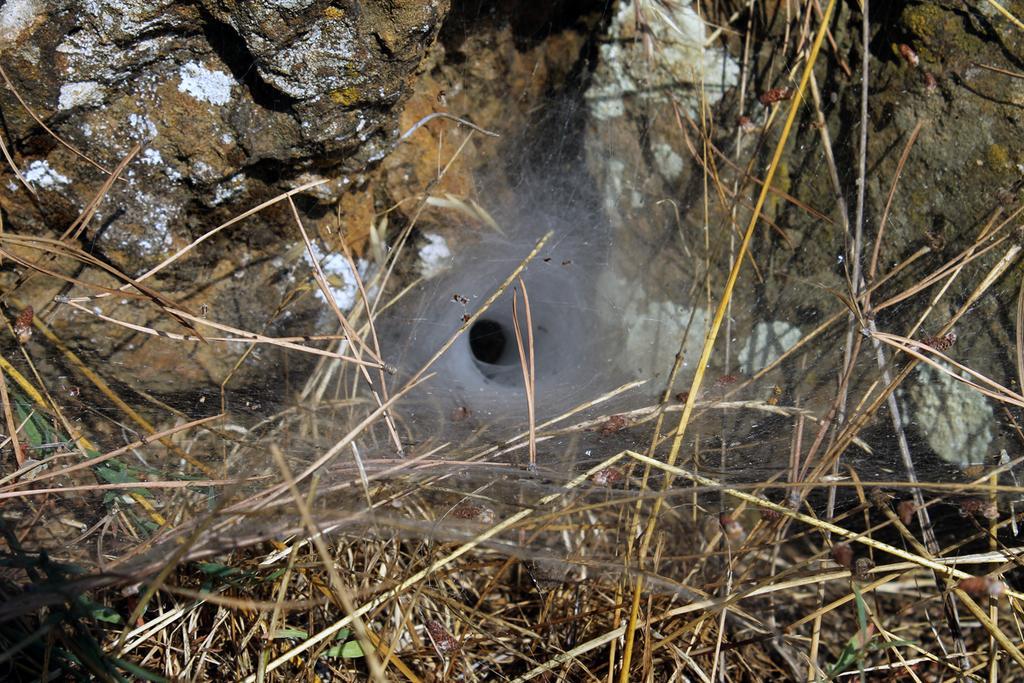Can you describe this image briefly? In this image I can see the grass. In the background, I can see it looks like a rock. 